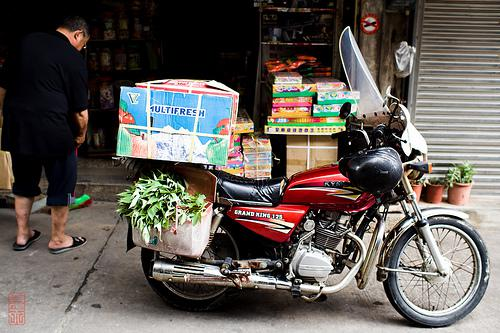Question: what color is the motorcycle seat?
Choices:
A. White.
B. Black.
C. Brown.
D. Red.
Answer with the letter. Answer: B Question: where are the pots?
Choices:
A. Beside the building.
B. In the kitchen.
C. On the table.
D. On the dinner table.
Answer with the letter. Answer: A Question: what color are the motorcycles spokes?
Choices:
A. Bronze.
B. Gold.
C. Black.
D. Silver.
Answer with the letter. Answer: D Question: what color are the leaves?
Choices:
A. Brown.
B. Red.
C. Green.
D. Yellow.
Answer with the letter. Answer: C 